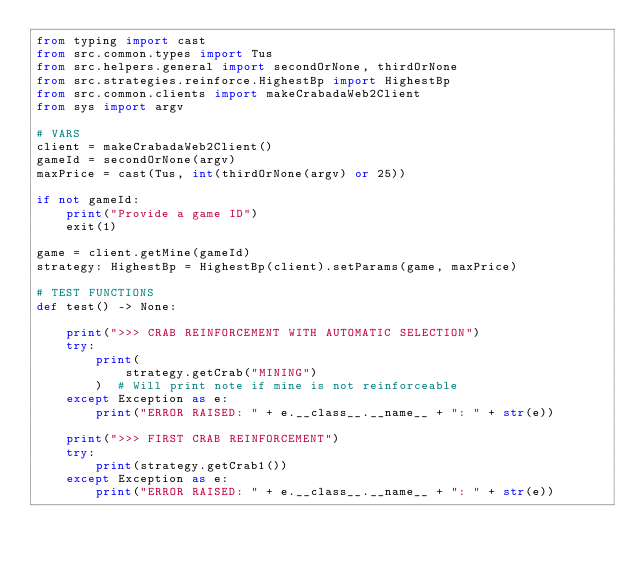<code> <loc_0><loc_0><loc_500><loc_500><_Python_>from typing import cast
from src.common.types import Tus
from src.helpers.general import secondOrNone, thirdOrNone
from src.strategies.reinforce.HighestBp import HighestBp
from src.common.clients import makeCrabadaWeb2Client
from sys import argv

# VARS
client = makeCrabadaWeb2Client()
gameId = secondOrNone(argv)
maxPrice = cast(Tus, int(thirdOrNone(argv) or 25))

if not gameId:
    print("Provide a game ID")
    exit(1)

game = client.getMine(gameId)
strategy: HighestBp = HighestBp(client).setParams(game, maxPrice)

# TEST FUNCTIONS
def test() -> None:

    print(">>> CRAB REINFORCEMENT WITH AUTOMATIC SELECTION")
    try:
        print(
            strategy.getCrab("MINING")
        )  # Will print note if mine is not reinforceable
    except Exception as e:
        print("ERROR RAISED: " + e.__class__.__name__ + ": " + str(e))

    print(">>> FIRST CRAB REINFORCEMENT")
    try:
        print(strategy.getCrab1())
    except Exception as e:
        print("ERROR RAISED: " + e.__class__.__name__ + ": " + str(e))
</code> 